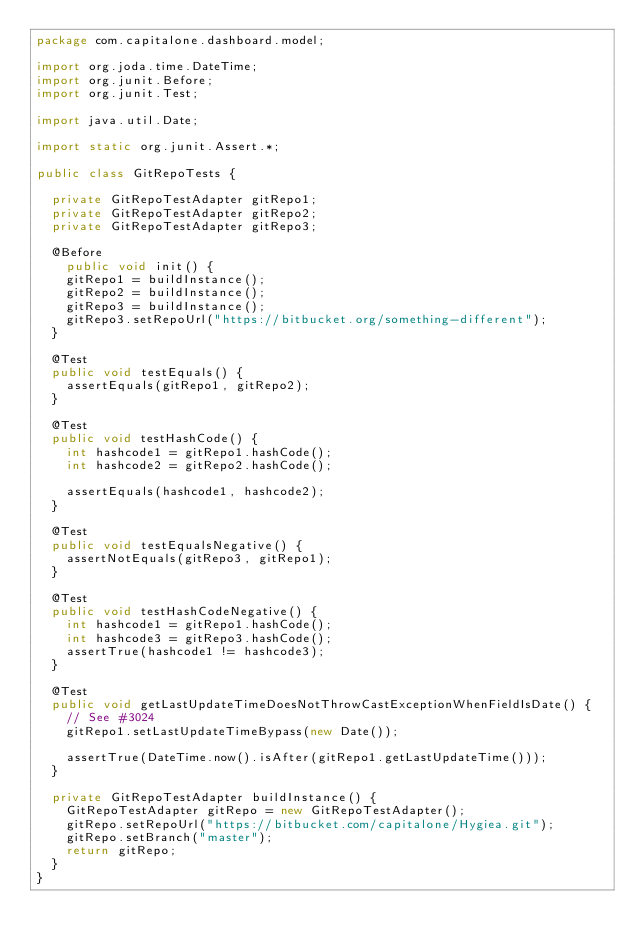Convert code to text. <code><loc_0><loc_0><loc_500><loc_500><_Java_>package com.capitalone.dashboard.model;

import org.joda.time.DateTime;
import org.junit.Before;
import org.junit.Test;

import java.util.Date;

import static org.junit.Assert.*;

public class GitRepoTests {

	private GitRepoTestAdapter gitRepo1;
	private GitRepoTestAdapter gitRepo2;
	private GitRepoTestAdapter gitRepo3;

	@Before
    public void init() {
		gitRepo1 = buildInstance();
		gitRepo2 = buildInstance();
		gitRepo3 = buildInstance();
		gitRepo3.setRepoUrl("https://bitbucket.org/something-different");
	}

	@Test
	public void testEquals() {
		assertEquals(gitRepo1, gitRepo2);
	}

	@Test
	public void testHashCode() {
		int hashcode1 = gitRepo1.hashCode();
		int hashcode2 = gitRepo2.hashCode();

		assertEquals(hashcode1, hashcode2);
	}

	@Test
	public void testEqualsNegative() {
		assertNotEquals(gitRepo3, gitRepo1);
	}

	@Test
	public void testHashCodeNegative() {
		int hashcode1 = gitRepo1.hashCode();
		int hashcode3 = gitRepo3.hashCode();
		assertTrue(hashcode1 != hashcode3);
	}

	@Test
	public void getLastUpdateTimeDoesNotThrowCastExceptionWhenFieldIsDate() {
		// See #3024
		gitRepo1.setLastUpdateTimeBypass(new Date());

		assertTrue(DateTime.now().isAfter(gitRepo1.getLastUpdateTime()));
	}

	private GitRepoTestAdapter buildInstance() {
		GitRepoTestAdapter gitRepo = new GitRepoTestAdapter();
		gitRepo.setRepoUrl("https://bitbucket.com/capitalone/Hygiea.git");
		gitRepo.setBranch("master");
		return gitRepo;
	}
}
</code> 